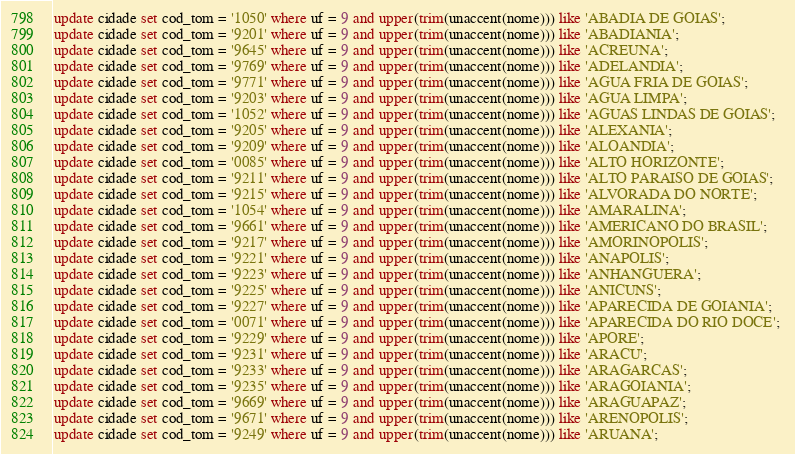Convert code to text. <code><loc_0><loc_0><loc_500><loc_500><_SQL_>update cidade set cod_tom = '1050' where uf = 9 and upper(trim(unaccent(nome))) like 'ABADIA DE GOIAS'; 
update cidade set cod_tom = '9201' where uf = 9 and upper(trim(unaccent(nome))) like 'ABADIANIA'; 
update cidade set cod_tom = '9645' where uf = 9 and upper(trim(unaccent(nome))) like 'ACREUNA'; 
update cidade set cod_tom = '9769' where uf = 9 and upper(trim(unaccent(nome))) like 'ADELANDIA'; 
update cidade set cod_tom = '9771' where uf = 9 and upper(trim(unaccent(nome))) like 'AGUA FRIA DE GOIAS'; 
update cidade set cod_tom = '9203' where uf = 9 and upper(trim(unaccent(nome))) like 'AGUA LIMPA'; 
update cidade set cod_tom = '1052' where uf = 9 and upper(trim(unaccent(nome))) like 'AGUAS LINDAS DE GOIAS'; 
update cidade set cod_tom = '9205' where uf = 9 and upper(trim(unaccent(nome))) like 'ALEXANIA'; 
update cidade set cod_tom = '9209' where uf = 9 and upper(trim(unaccent(nome))) like 'ALOANDIA'; 
update cidade set cod_tom = '0085' where uf = 9 and upper(trim(unaccent(nome))) like 'ALTO HORIZONTE'; 
update cidade set cod_tom = '9211' where uf = 9 and upper(trim(unaccent(nome))) like 'ALTO PARAISO DE GOIAS'; 
update cidade set cod_tom = '9215' where uf = 9 and upper(trim(unaccent(nome))) like 'ALVORADA DO NORTE'; 
update cidade set cod_tom = '1054' where uf = 9 and upper(trim(unaccent(nome))) like 'AMARALINA'; 
update cidade set cod_tom = '9661' where uf = 9 and upper(trim(unaccent(nome))) like 'AMERICANO DO BRASIL'; 
update cidade set cod_tom = '9217' where uf = 9 and upper(trim(unaccent(nome))) like 'AMORINOPOLIS'; 
update cidade set cod_tom = '9221' where uf = 9 and upper(trim(unaccent(nome))) like 'ANAPOLIS'; 
update cidade set cod_tom = '9223' where uf = 9 and upper(trim(unaccent(nome))) like 'ANHANGUERA'; 
update cidade set cod_tom = '9225' where uf = 9 and upper(trim(unaccent(nome))) like 'ANICUNS'; 
update cidade set cod_tom = '9227' where uf = 9 and upper(trim(unaccent(nome))) like 'APARECIDA DE GOIANIA'; 
update cidade set cod_tom = '0071' where uf = 9 and upper(trim(unaccent(nome))) like 'APARECIDA DO RIO DOCE'; 
update cidade set cod_tom = '9229' where uf = 9 and upper(trim(unaccent(nome))) like 'APORE'; 
update cidade set cod_tom = '9231' where uf = 9 and upper(trim(unaccent(nome))) like 'ARACU'; 
update cidade set cod_tom = '9233' where uf = 9 and upper(trim(unaccent(nome))) like 'ARAGARCAS'; 
update cidade set cod_tom = '9235' where uf = 9 and upper(trim(unaccent(nome))) like 'ARAGOIANIA'; 
update cidade set cod_tom = '9669' where uf = 9 and upper(trim(unaccent(nome))) like 'ARAGUAPAZ'; 
update cidade set cod_tom = '9671' where uf = 9 and upper(trim(unaccent(nome))) like 'ARENOPOLIS'; 
update cidade set cod_tom = '9249' where uf = 9 and upper(trim(unaccent(nome))) like 'ARUANA'; </code> 